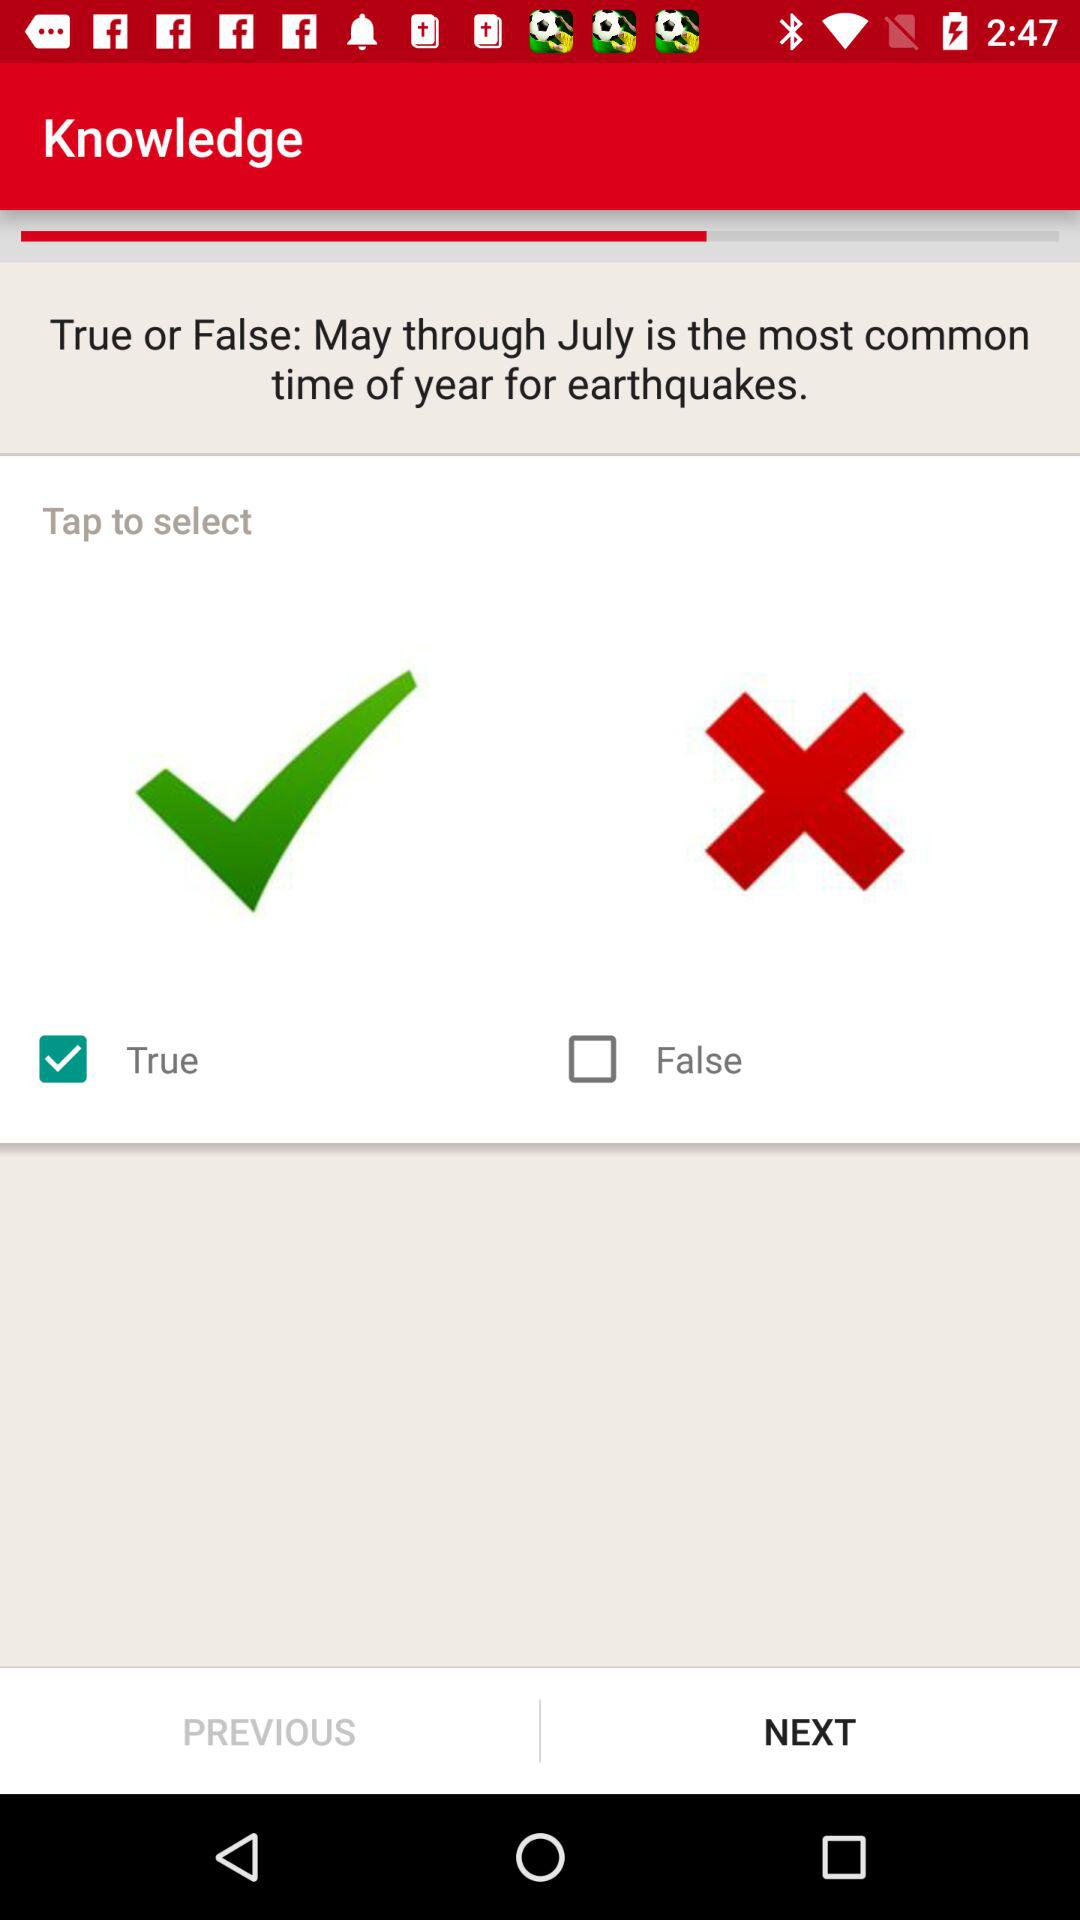What month is most common for earthquakes? The most common month for earthquake is "May through July". 